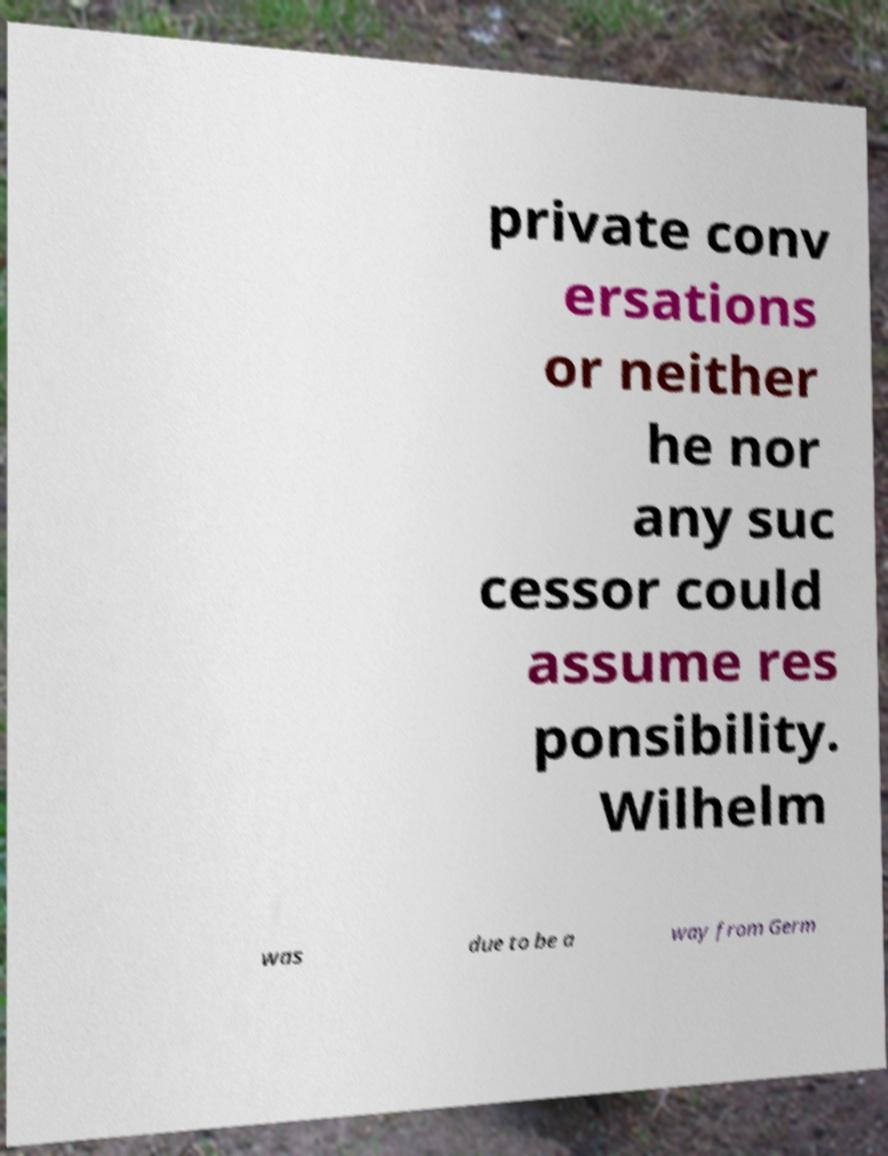Can you read and provide the text displayed in the image?This photo seems to have some interesting text. Can you extract and type it out for me? private conv ersations or neither he nor any suc cessor could assume res ponsibility. Wilhelm was due to be a way from Germ 